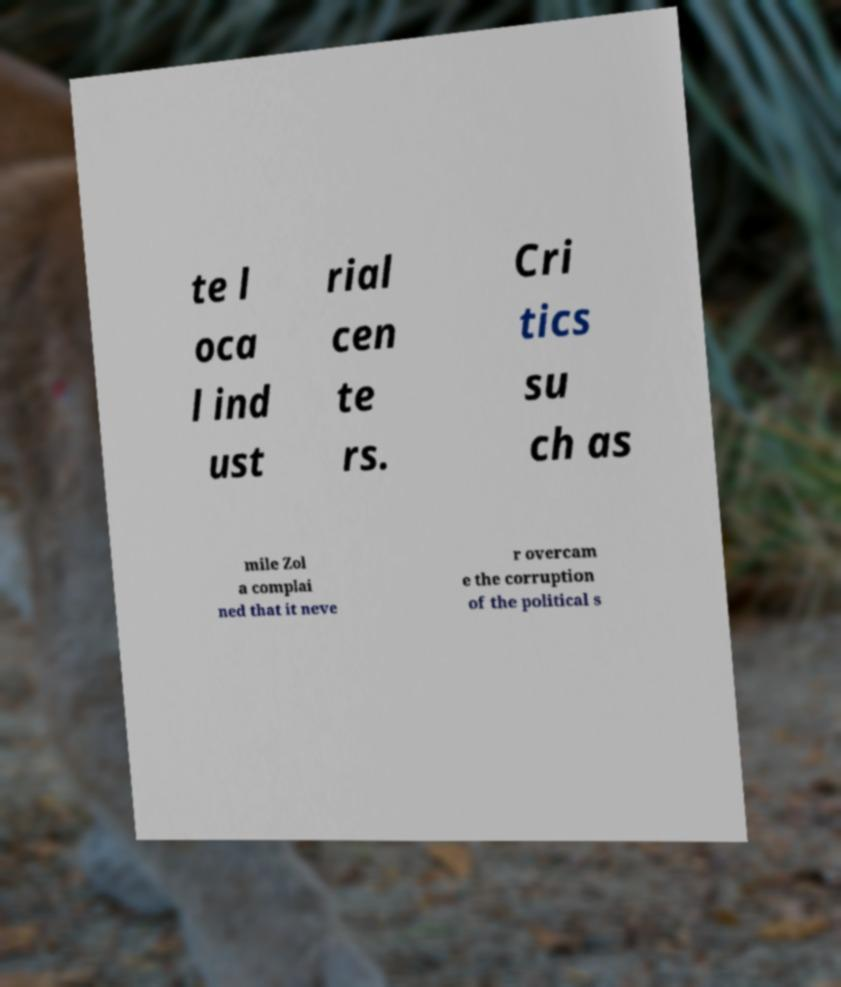There's text embedded in this image that I need extracted. Can you transcribe it verbatim? te l oca l ind ust rial cen te rs. Cri tics su ch as mile Zol a complai ned that it neve r overcam e the corruption of the political s 